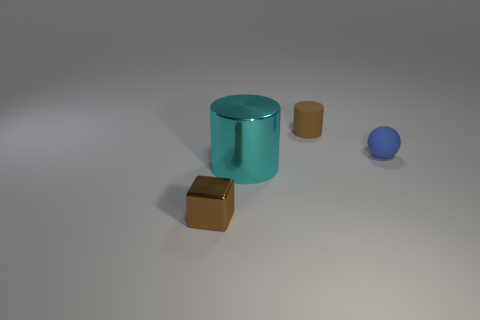Do the small brown cylinder and the small object that is to the left of the brown rubber cylinder have the same material?
Make the answer very short. No. The brown object that is to the left of the matte thing behind the tiny blue sphere is what shape?
Offer a very short reply. Cube. Does the tiny cylinder have the same color as the small object to the left of the small brown matte object?
Provide a succinct answer. Yes. There is a tiny blue rubber thing; what shape is it?
Your answer should be compact. Sphere. There is a brown thing right of the small object that is in front of the blue matte ball; how big is it?
Your response must be concise. Small. Are there the same number of cyan objects in front of the tiny brown metallic object and tiny rubber objects that are on the right side of the small cylinder?
Offer a very short reply. No. What is the small thing that is both left of the tiny blue matte thing and in front of the brown matte cylinder made of?
Your answer should be compact. Metal. Does the brown cylinder have the same size as the brown object to the left of the brown rubber cylinder?
Make the answer very short. Yes. How many other objects are the same color as the large thing?
Your response must be concise. 0. Is the number of blocks that are left of the big object greater than the number of green metal balls?
Make the answer very short. Yes. 